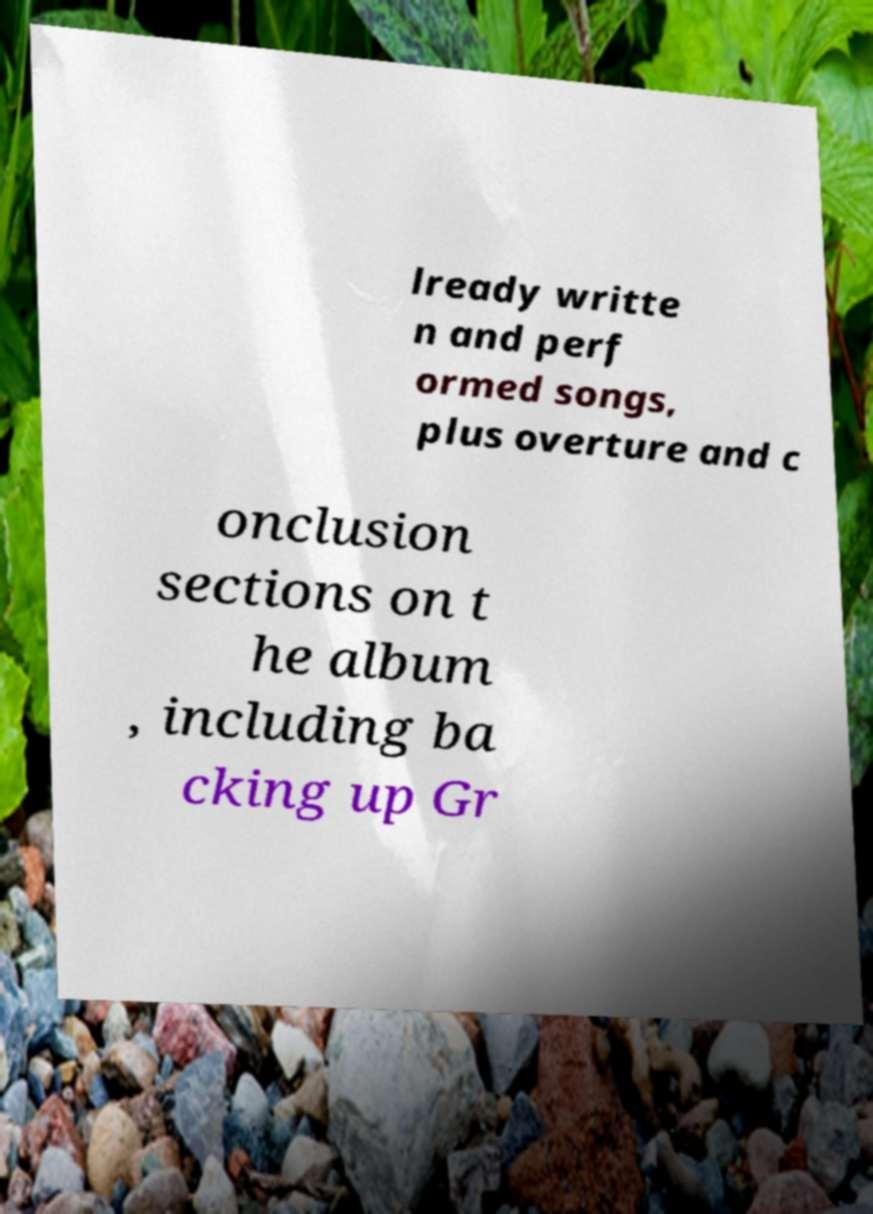Please identify and transcribe the text found in this image. lready writte n and perf ormed songs, plus overture and c onclusion sections on t he album , including ba cking up Gr 